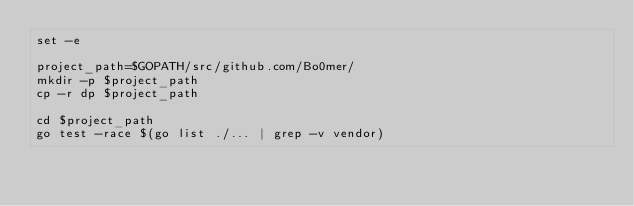<code> <loc_0><loc_0><loc_500><loc_500><_Bash_>set -e

project_path=$GOPATH/src/github.com/Bo0mer/
mkdir -p $project_path
cp -r dp $project_path

cd $project_path
go test -race $(go list ./... | grep -v vendor)
</code> 